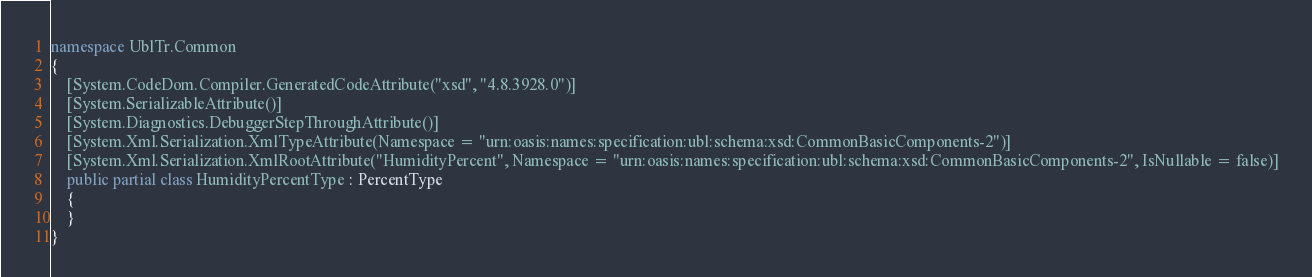Convert code to text. <code><loc_0><loc_0><loc_500><loc_500><_C#_>namespace UblTr.Common
{
    [System.CodeDom.Compiler.GeneratedCodeAttribute("xsd", "4.8.3928.0")]
    [System.SerializableAttribute()]
    [System.Diagnostics.DebuggerStepThroughAttribute()]
    [System.Xml.Serialization.XmlTypeAttribute(Namespace = "urn:oasis:names:specification:ubl:schema:xsd:CommonBasicComponents-2")]
    [System.Xml.Serialization.XmlRootAttribute("HumidityPercent", Namespace = "urn:oasis:names:specification:ubl:schema:xsd:CommonBasicComponents-2", IsNullable = false)]
    public partial class HumidityPercentType : PercentType
    {
    }
}</code> 